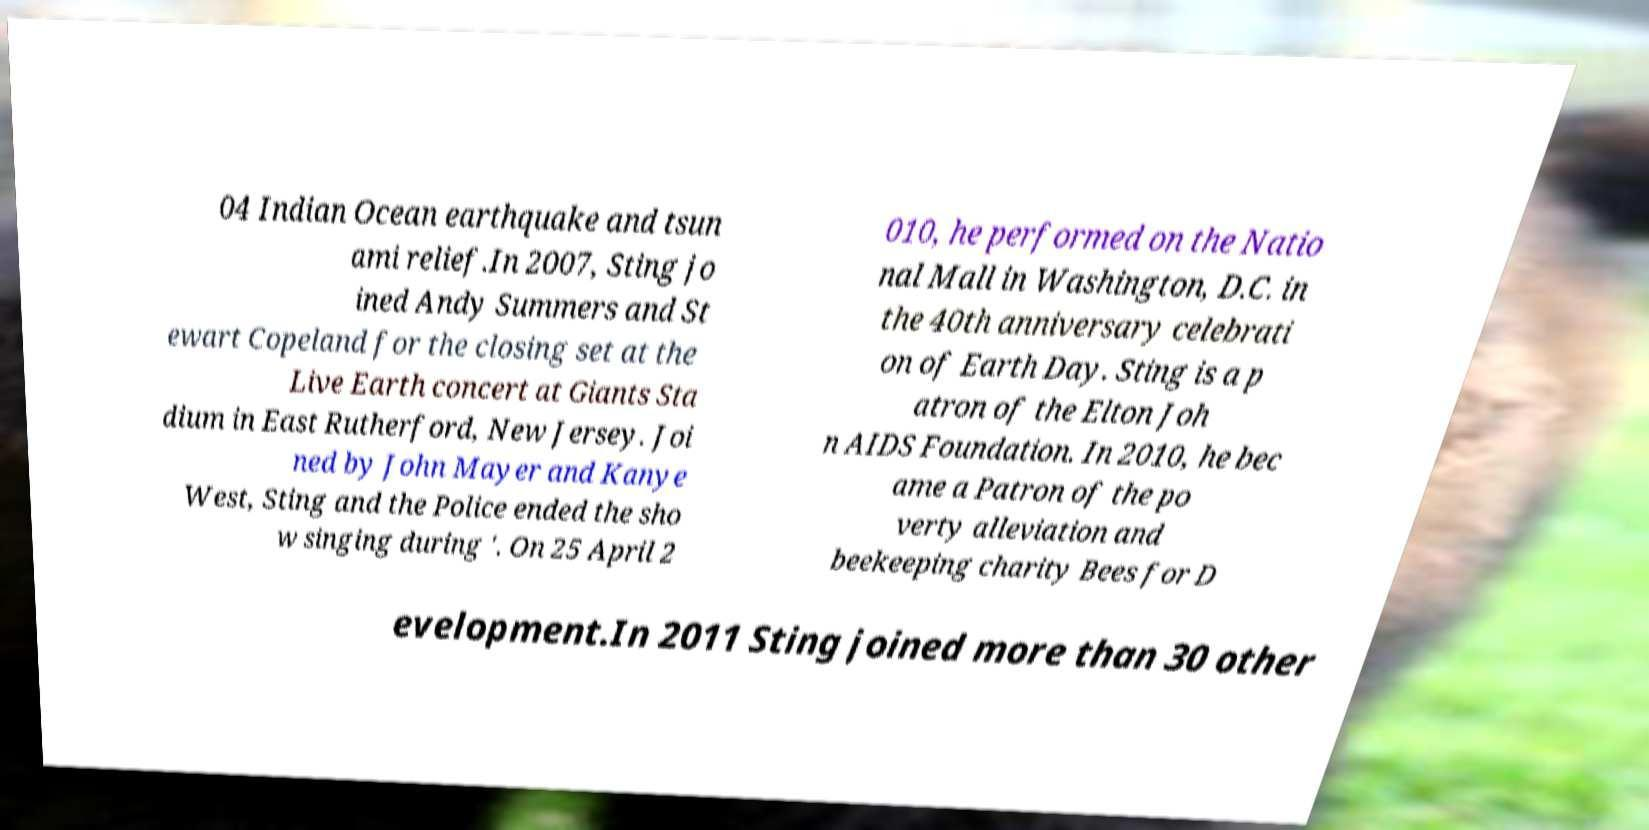For documentation purposes, I need the text within this image transcribed. Could you provide that? 04 Indian Ocean earthquake and tsun ami relief.In 2007, Sting jo ined Andy Summers and St ewart Copeland for the closing set at the Live Earth concert at Giants Sta dium in East Rutherford, New Jersey. Joi ned by John Mayer and Kanye West, Sting and the Police ended the sho w singing during '. On 25 April 2 010, he performed on the Natio nal Mall in Washington, D.C. in the 40th anniversary celebrati on of Earth Day. Sting is a p atron of the Elton Joh n AIDS Foundation. In 2010, he bec ame a Patron of the po verty alleviation and beekeeping charity Bees for D evelopment.In 2011 Sting joined more than 30 other 